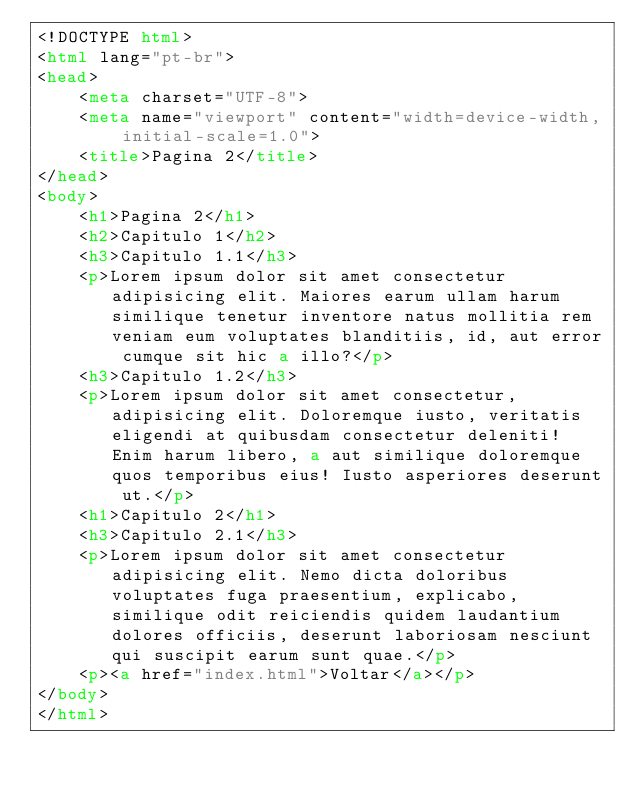Convert code to text. <code><loc_0><loc_0><loc_500><loc_500><_HTML_><!DOCTYPE html>
<html lang="pt-br">
<head>
    <meta charset="UTF-8">
    <meta name="viewport" content="width=device-width, initial-scale=1.0">
    <title>Pagina 2</title>
</head>
<body>
    <h1>Pagina 2</h1>
    <h2>Capitulo 1</h2>
    <h3>Capitulo 1.1</h3>
    <p>Lorem ipsum dolor sit amet consectetur adipisicing elit. Maiores earum ullam harum similique tenetur inventore natus mollitia rem veniam eum voluptates blanditiis, id, aut error cumque sit hic a illo?</p>
    <h3>Capitulo 1.2</h3>
    <p>Lorem ipsum dolor sit amet consectetur, adipisicing elit. Doloremque iusto, veritatis eligendi at quibusdam consectetur deleniti! Enim harum libero, a aut similique doloremque quos temporibus eius! Iusto asperiores deserunt ut.</p>
    <h1>Capitulo 2</h1>
    <h3>Capitulo 2.1</h3>
    <p>Lorem ipsum dolor sit amet consectetur adipisicing elit. Nemo dicta doloribus voluptates fuga praesentium, explicabo, similique odit reiciendis quidem laudantium dolores officiis, deserunt laboriosam nesciunt qui suscipit earum sunt quae.</p>
    <p><a href="index.html">Voltar</a></p>
</body>
</html></code> 